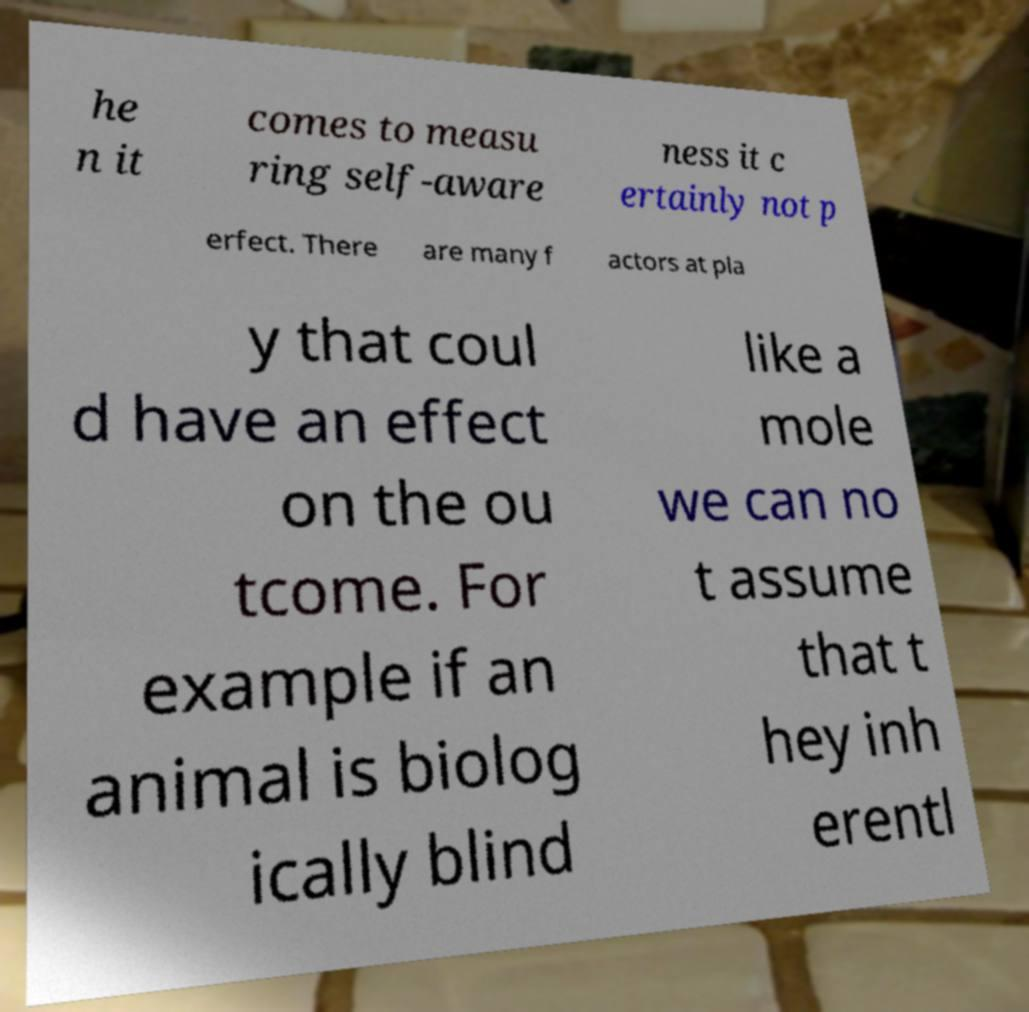Please identify and transcribe the text found in this image. he n it comes to measu ring self-aware ness it c ertainly not p erfect. There are many f actors at pla y that coul d have an effect on the ou tcome. For example if an animal is biolog ically blind like a mole we can no t assume that t hey inh erentl 